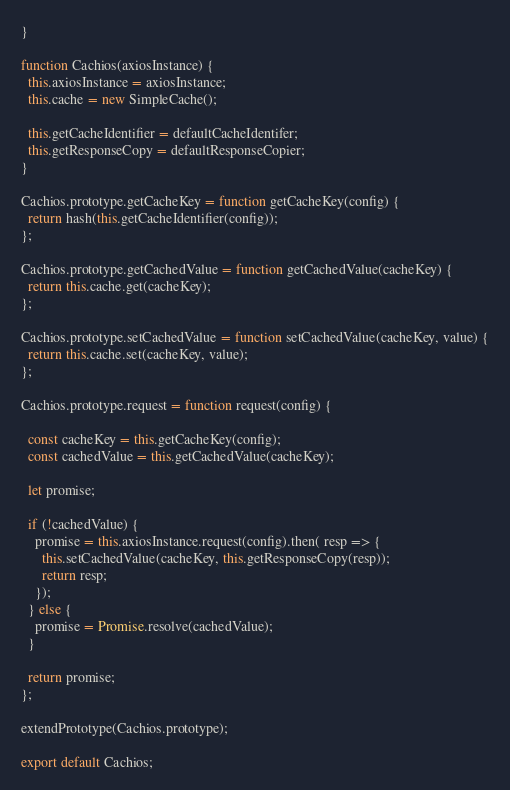Convert code to text. <code><loc_0><loc_0><loc_500><loc_500><_JavaScript_>}

function Cachios(axiosInstance) {
  this.axiosInstance = axiosInstance;
  this.cache = new SimpleCache();

  this.getCacheIdentifier = defaultCacheIdentifer;
  this.getResponseCopy = defaultResponseCopier;
}

Cachios.prototype.getCacheKey = function getCacheKey(config) {
  return hash(this.getCacheIdentifier(config));
};

Cachios.prototype.getCachedValue = function getCachedValue(cacheKey) {
  return this.cache.get(cacheKey);
};

Cachios.prototype.setCachedValue = function setCachedValue(cacheKey, value) {
  return this.cache.set(cacheKey, value);
};

Cachios.prototype.request = function request(config) {  
  
  const cacheKey = this.getCacheKey(config);
  const cachedValue = this.getCachedValue(cacheKey);

  let promise;

  if (!cachedValue) {
    promise = this.axiosInstance.request(config).then( resp => {      
      this.setCachedValue(cacheKey, this.getResponseCopy(resp));
      return resp;
    });
  } else {
    promise = Promise.resolve(cachedValue);
  }

  return promise;
};

extendPrototype(Cachios.prototype);

export default Cachios;
</code> 